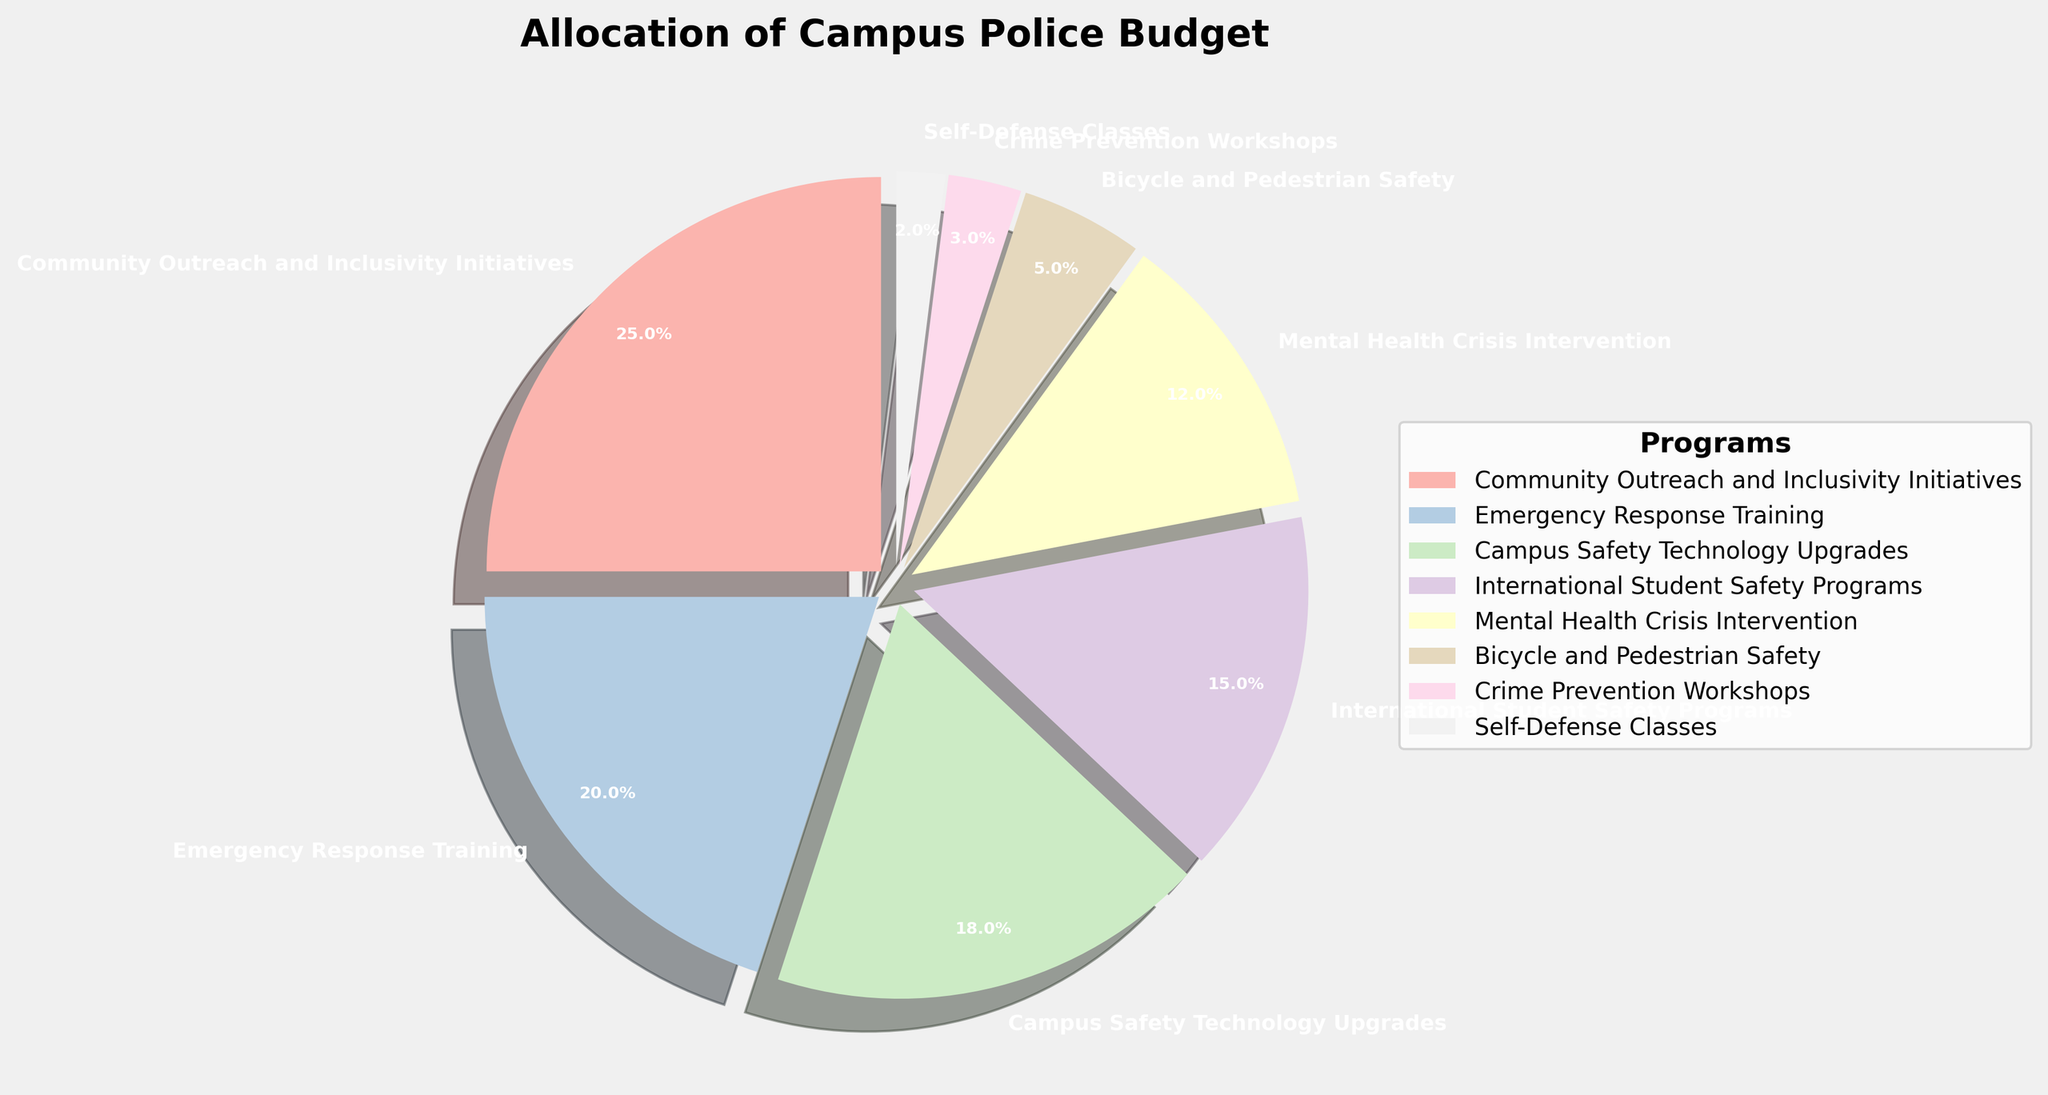Which program received the largest portion of the campus police budget? Looking at the pie chart, the "Community Outreach and Inclusivity Initiatives" segment is the largest slice, indicating it received the largest portion of the budget.
Answer: Community Outreach and Inclusivity Initiatives Which two programs together constitute the smallest portion of the total budget? By examining the pie chart, "Crime Prevention Workshops" and "Self-Defense Classes" are the two smallest segments. Adding their portions (3% + 2%) confirms they constitute the smallest portion together.
Answer: Crime Prevention Workshops and Self-Defense Classes How much more budget allocation does "Emergency Response Training" have compared to "Mental Health Crisis Intervention"? From the pie chart, "Emergency Response Training" has an allocation of 20%, while "Mental Health Crisis Intervention" has 12%. Subtracting these values gives the difference, which is 20% - 12% = 8%.
Answer: 8% By what percentage does "International Student Safety Programs" exceed "Bicycle and Pedestrian Safety"? The pie chart shows "International Student Safety Programs" at 15% and "Bicycle and Pedestrian Safety" at 5%. The difference is 15% - 5% = 10%.
Answer: 10% If we combine "Campus Safety Technology Upgrades" and "Mental Health Crisis Intervention," what percentage of the total budget do they represent together? Looking at the pie chart, "Campus Safety Technology Upgrades" is 18% and "Mental Health Crisis Intervention" is 12%. Summing these percentages gives 18% + 12% = 30%.
Answer: 30% What is the visual style used to differentiate the budget allocations in the pie chart? The pie chart uses different pastel colors and an "explode" effect to visually distinguish between the different budget allocations.
Answer: Different pastel colors and "explode" effect Among the given programs, which received the closest allocation to one-fourth of the total budget? Referring to the pie chart, "Community Outreach and Inclusivity Initiatives" received 25% of the budget, which is exactly one-fourth of the total budget.
Answer: Community Outreach and Inclusivity Initiatives If you combine the budget allocation of the two smallest programs, how does their total compare to the "Bicycle and Pedestrian Safety" program? The two smallest programs are "Crime Prevention Workshops" (3%) and "Self-Defense Classes" (2%). Together they total 5%, which is equal to the "Bicycle and Pedestrian Safety" program's 5%.
Answer: Equal 